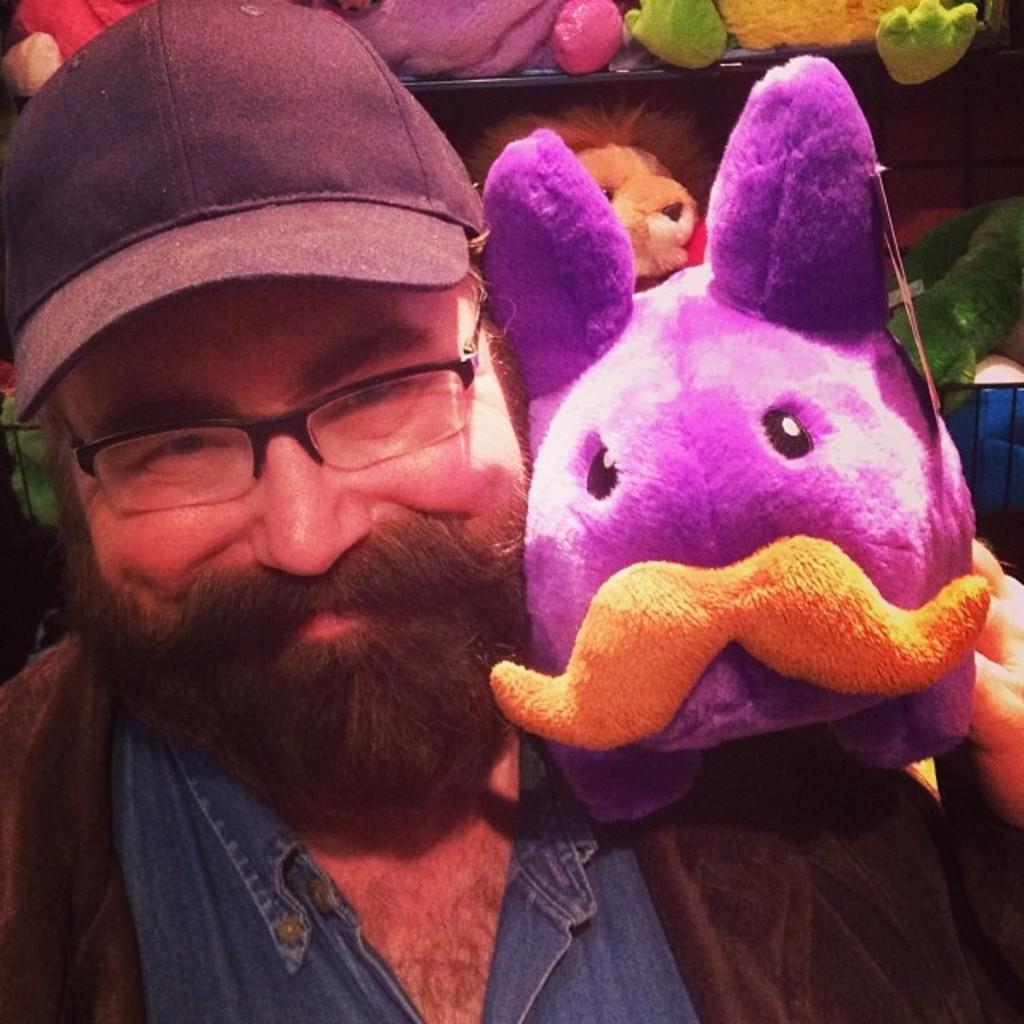Who is present in the image? There is a man in the image. What is the man wearing on his head? The man is wearing a cap. What other objects or figures can be seen in the image? There are dolls in the image. What type of stamp can be seen on the man's hand in the image? There is no stamp visible on the man's hand in the image. 